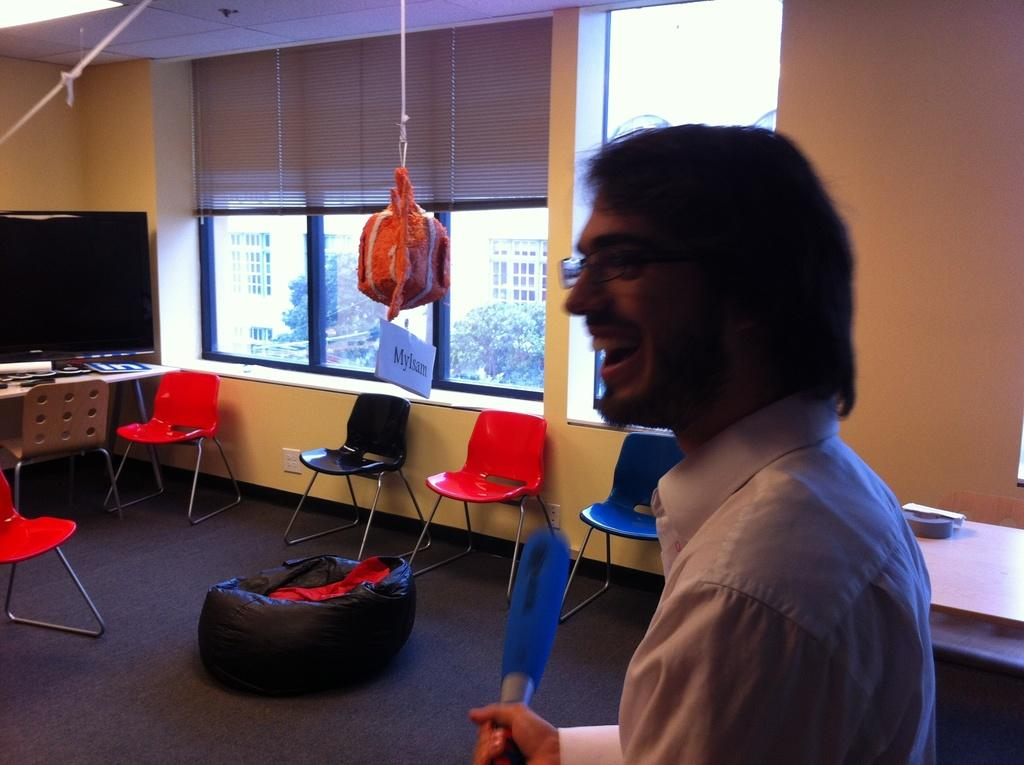Who or what is present in the image? There is a person in the image. What furniture can be seen in the image? There are chairs in the image. What can be seen in the background of the image? There is a window in the background of the image. What electronic device is visible in the image? There is a television in the image. What is hanging from the ceiling in the image? There is an object hanged to the ceiling in the image. Can you see any eggs in the image? There are no eggs present in the image. Is there an arch visible in the image? There is no arch visible in the image. 